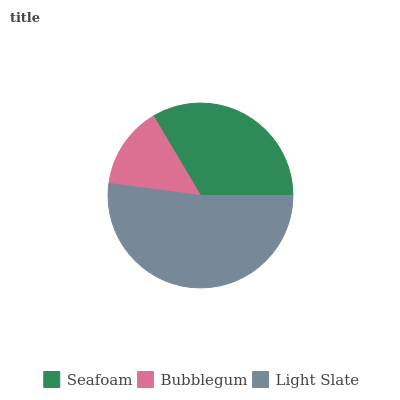Is Bubblegum the minimum?
Answer yes or no. Yes. Is Light Slate the maximum?
Answer yes or no. Yes. Is Light Slate the minimum?
Answer yes or no. No. Is Bubblegum the maximum?
Answer yes or no. No. Is Light Slate greater than Bubblegum?
Answer yes or no. Yes. Is Bubblegum less than Light Slate?
Answer yes or no. Yes. Is Bubblegum greater than Light Slate?
Answer yes or no. No. Is Light Slate less than Bubblegum?
Answer yes or no. No. Is Seafoam the high median?
Answer yes or no. Yes. Is Seafoam the low median?
Answer yes or no. Yes. Is Light Slate the high median?
Answer yes or no. No. Is Light Slate the low median?
Answer yes or no. No. 